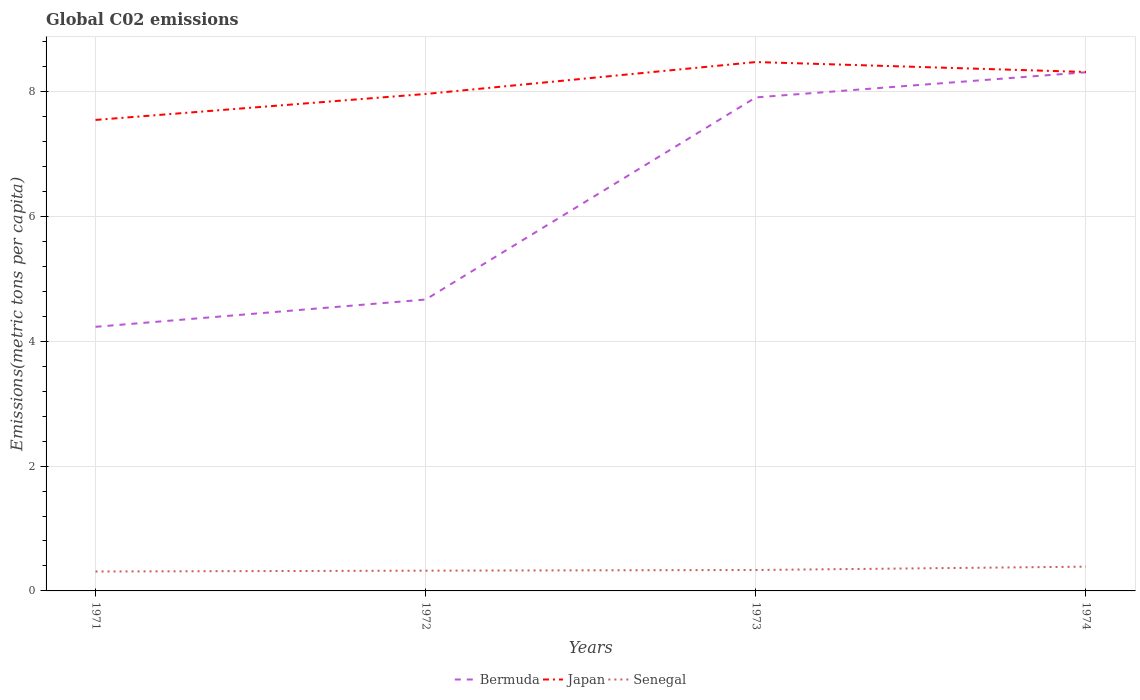Is the number of lines equal to the number of legend labels?
Your answer should be very brief. Yes. Across all years, what is the maximum amount of CO2 emitted in in Senegal?
Ensure brevity in your answer.  0.31. What is the total amount of CO2 emitted in in Senegal in the graph?
Give a very brief answer. -0.06. What is the difference between the highest and the second highest amount of CO2 emitted in in Senegal?
Offer a terse response. 0.08. Is the amount of CO2 emitted in in Japan strictly greater than the amount of CO2 emitted in in Senegal over the years?
Give a very brief answer. No. How many lines are there?
Give a very brief answer. 3. What is the difference between two consecutive major ticks on the Y-axis?
Provide a succinct answer. 2. Are the values on the major ticks of Y-axis written in scientific E-notation?
Offer a terse response. No. Does the graph contain any zero values?
Your response must be concise. No. Does the graph contain grids?
Give a very brief answer. Yes. How many legend labels are there?
Provide a succinct answer. 3. What is the title of the graph?
Your answer should be compact. Global C02 emissions. What is the label or title of the Y-axis?
Provide a succinct answer. Emissions(metric tons per capita). What is the Emissions(metric tons per capita) of Bermuda in 1971?
Keep it short and to the point. 4.23. What is the Emissions(metric tons per capita) in Japan in 1971?
Offer a very short reply. 7.55. What is the Emissions(metric tons per capita) of Senegal in 1971?
Ensure brevity in your answer.  0.31. What is the Emissions(metric tons per capita) of Bermuda in 1972?
Your answer should be very brief. 4.67. What is the Emissions(metric tons per capita) in Japan in 1972?
Offer a very short reply. 7.96. What is the Emissions(metric tons per capita) of Senegal in 1972?
Provide a succinct answer. 0.32. What is the Emissions(metric tons per capita) in Bermuda in 1973?
Provide a succinct answer. 7.91. What is the Emissions(metric tons per capita) of Japan in 1973?
Provide a short and direct response. 8.47. What is the Emissions(metric tons per capita) of Senegal in 1973?
Provide a succinct answer. 0.34. What is the Emissions(metric tons per capita) in Bermuda in 1974?
Your answer should be very brief. 8.31. What is the Emissions(metric tons per capita) of Japan in 1974?
Provide a succinct answer. 8.31. What is the Emissions(metric tons per capita) in Senegal in 1974?
Ensure brevity in your answer.  0.39. Across all years, what is the maximum Emissions(metric tons per capita) of Bermuda?
Your response must be concise. 8.31. Across all years, what is the maximum Emissions(metric tons per capita) of Japan?
Your response must be concise. 8.47. Across all years, what is the maximum Emissions(metric tons per capita) of Senegal?
Offer a terse response. 0.39. Across all years, what is the minimum Emissions(metric tons per capita) of Bermuda?
Provide a short and direct response. 4.23. Across all years, what is the minimum Emissions(metric tons per capita) in Japan?
Offer a very short reply. 7.55. Across all years, what is the minimum Emissions(metric tons per capita) in Senegal?
Your response must be concise. 0.31. What is the total Emissions(metric tons per capita) of Bermuda in the graph?
Make the answer very short. 25.12. What is the total Emissions(metric tons per capita) in Japan in the graph?
Provide a succinct answer. 32.29. What is the total Emissions(metric tons per capita) of Senegal in the graph?
Give a very brief answer. 1.36. What is the difference between the Emissions(metric tons per capita) in Bermuda in 1971 and that in 1972?
Your answer should be compact. -0.44. What is the difference between the Emissions(metric tons per capita) in Japan in 1971 and that in 1972?
Your response must be concise. -0.42. What is the difference between the Emissions(metric tons per capita) of Senegal in 1971 and that in 1972?
Your response must be concise. -0.01. What is the difference between the Emissions(metric tons per capita) of Bermuda in 1971 and that in 1973?
Make the answer very short. -3.68. What is the difference between the Emissions(metric tons per capita) in Japan in 1971 and that in 1973?
Provide a short and direct response. -0.93. What is the difference between the Emissions(metric tons per capita) of Senegal in 1971 and that in 1973?
Give a very brief answer. -0.02. What is the difference between the Emissions(metric tons per capita) in Bermuda in 1971 and that in 1974?
Your answer should be compact. -4.08. What is the difference between the Emissions(metric tons per capita) of Japan in 1971 and that in 1974?
Offer a terse response. -0.77. What is the difference between the Emissions(metric tons per capita) in Senegal in 1971 and that in 1974?
Give a very brief answer. -0.08. What is the difference between the Emissions(metric tons per capita) of Bermuda in 1972 and that in 1973?
Ensure brevity in your answer.  -3.24. What is the difference between the Emissions(metric tons per capita) of Japan in 1972 and that in 1973?
Your response must be concise. -0.51. What is the difference between the Emissions(metric tons per capita) in Senegal in 1972 and that in 1973?
Provide a short and direct response. -0.01. What is the difference between the Emissions(metric tons per capita) of Bermuda in 1972 and that in 1974?
Give a very brief answer. -3.64. What is the difference between the Emissions(metric tons per capita) of Japan in 1972 and that in 1974?
Ensure brevity in your answer.  -0.35. What is the difference between the Emissions(metric tons per capita) of Senegal in 1972 and that in 1974?
Offer a terse response. -0.06. What is the difference between the Emissions(metric tons per capita) in Bermuda in 1973 and that in 1974?
Give a very brief answer. -0.4. What is the difference between the Emissions(metric tons per capita) in Japan in 1973 and that in 1974?
Your answer should be very brief. 0.16. What is the difference between the Emissions(metric tons per capita) in Senegal in 1973 and that in 1974?
Your answer should be compact. -0.05. What is the difference between the Emissions(metric tons per capita) in Bermuda in 1971 and the Emissions(metric tons per capita) in Japan in 1972?
Provide a short and direct response. -3.73. What is the difference between the Emissions(metric tons per capita) of Bermuda in 1971 and the Emissions(metric tons per capita) of Senegal in 1972?
Offer a terse response. 3.91. What is the difference between the Emissions(metric tons per capita) of Japan in 1971 and the Emissions(metric tons per capita) of Senegal in 1972?
Keep it short and to the point. 7.22. What is the difference between the Emissions(metric tons per capita) of Bermuda in 1971 and the Emissions(metric tons per capita) of Japan in 1973?
Provide a short and direct response. -4.24. What is the difference between the Emissions(metric tons per capita) in Bermuda in 1971 and the Emissions(metric tons per capita) in Senegal in 1973?
Offer a very short reply. 3.9. What is the difference between the Emissions(metric tons per capita) of Japan in 1971 and the Emissions(metric tons per capita) of Senegal in 1973?
Ensure brevity in your answer.  7.21. What is the difference between the Emissions(metric tons per capita) in Bermuda in 1971 and the Emissions(metric tons per capita) in Japan in 1974?
Give a very brief answer. -4.08. What is the difference between the Emissions(metric tons per capita) of Bermuda in 1971 and the Emissions(metric tons per capita) of Senegal in 1974?
Give a very brief answer. 3.84. What is the difference between the Emissions(metric tons per capita) of Japan in 1971 and the Emissions(metric tons per capita) of Senegal in 1974?
Offer a very short reply. 7.16. What is the difference between the Emissions(metric tons per capita) in Bermuda in 1972 and the Emissions(metric tons per capita) in Japan in 1973?
Ensure brevity in your answer.  -3.8. What is the difference between the Emissions(metric tons per capita) in Bermuda in 1972 and the Emissions(metric tons per capita) in Senegal in 1973?
Offer a very short reply. 4.33. What is the difference between the Emissions(metric tons per capita) of Japan in 1972 and the Emissions(metric tons per capita) of Senegal in 1973?
Provide a short and direct response. 7.63. What is the difference between the Emissions(metric tons per capita) in Bermuda in 1972 and the Emissions(metric tons per capita) in Japan in 1974?
Your answer should be compact. -3.65. What is the difference between the Emissions(metric tons per capita) of Bermuda in 1972 and the Emissions(metric tons per capita) of Senegal in 1974?
Offer a terse response. 4.28. What is the difference between the Emissions(metric tons per capita) in Japan in 1972 and the Emissions(metric tons per capita) in Senegal in 1974?
Make the answer very short. 7.57. What is the difference between the Emissions(metric tons per capita) of Bermuda in 1973 and the Emissions(metric tons per capita) of Japan in 1974?
Make the answer very short. -0.41. What is the difference between the Emissions(metric tons per capita) of Bermuda in 1973 and the Emissions(metric tons per capita) of Senegal in 1974?
Ensure brevity in your answer.  7.52. What is the difference between the Emissions(metric tons per capita) of Japan in 1973 and the Emissions(metric tons per capita) of Senegal in 1974?
Offer a terse response. 8.08. What is the average Emissions(metric tons per capita) of Bermuda per year?
Offer a terse response. 6.28. What is the average Emissions(metric tons per capita) in Japan per year?
Your answer should be compact. 8.07. What is the average Emissions(metric tons per capita) in Senegal per year?
Offer a terse response. 0.34. In the year 1971, what is the difference between the Emissions(metric tons per capita) in Bermuda and Emissions(metric tons per capita) in Japan?
Your answer should be compact. -3.31. In the year 1971, what is the difference between the Emissions(metric tons per capita) of Bermuda and Emissions(metric tons per capita) of Senegal?
Ensure brevity in your answer.  3.92. In the year 1971, what is the difference between the Emissions(metric tons per capita) in Japan and Emissions(metric tons per capita) in Senegal?
Offer a terse response. 7.23. In the year 1972, what is the difference between the Emissions(metric tons per capita) of Bermuda and Emissions(metric tons per capita) of Japan?
Give a very brief answer. -3.29. In the year 1972, what is the difference between the Emissions(metric tons per capita) in Bermuda and Emissions(metric tons per capita) in Senegal?
Keep it short and to the point. 4.34. In the year 1972, what is the difference between the Emissions(metric tons per capita) of Japan and Emissions(metric tons per capita) of Senegal?
Provide a succinct answer. 7.64. In the year 1973, what is the difference between the Emissions(metric tons per capita) in Bermuda and Emissions(metric tons per capita) in Japan?
Make the answer very short. -0.57. In the year 1973, what is the difference between the Emissions(metric tons per capita) in Bermuda and Emissions(metric tons per capita) in Senegal?
Provide a succinct answer. 7.57. In the year 1973, what is the difference between the Emissions(metric tons per capita) in Japan and Emissions(metric tons per capita) in Senegal?
Offer a terse response. 8.14. In the year 1974, what is the difference between the Emissions(metric tons per capita) of Bermuda and Emissions(metric tons per capita) of Japan?
Give a very brief answer. -0. In the year 1974, what is the difference between the Emissions(metric tons per capita) of Bermuda and Emissions(metric tons per capita) of Senegal?
Make the answer very short. 7.92. In the year 1974, what is the difference between the Emissions(metric tons per capita) of Japan and Emissions(metric tons per capita) of Senegal?
Your answer should be very brief. 7.93. What is the ratio of the Emissions(metric tons per capita) in Bermuda in 1971 to that in 1972?
Your answer should be compact. 0.91. What is the ratio of the Emissions(metric tons per capita) of Japan in 1971 to that in 1972?
Keep it short and to the point. 0.95. What is the ratio of the Emissions(metric tons per capita) of Senegal in 1971 to that in 1972?
Make the answer very short. 0.96. What is the ratio of the Emissions(metric tons per capita) in Bermuda in 1971 to that in 1973?
Your answer should be compact. 0.54. What is the ratio of the Emissions(metric tons per capita) of Japan in 1971 to that in 1973?
Provide a succinct answer. 0.89. What is the ratio of the Emissions(metric tons per capita) in Senegal in 1971 to that in 1973?
Ensure brevity in your answer.  0.93. What is the ratio of the Emissions(metric tons per capita) in Bermuda in 1971 to that in 1974?
Your answer should be very brief. 0.51. What is the ratio of the Emissions(metric tons per capita) of Japan in 1971 to that in 1974?
Your response must be concise. 0.91. What is the ratio of the Emissions(metric tons per capita) in Senegal in 1971 to that in 1974?
Provide a succinct answer. 0.8. What is the ratio of the Emissions(metric tons per capita) of Bermuda in 1972 to that in 1973?
Offer a terse response. 0.59. What is the ratio of the Emissions(metric tons per capita) in Japan in 1972 to that in 1973?
Your response must be concise. 0.94. What is the ratio of the Emissions(metric tons per capita) of Senegal in 1972 to that in 1973?
Your answer should be compact. 0.97. What is the ratio of the Emissions(metric tons per capita) of Bermuda in 1972 to that in 1974?
Offer a very short reply. 0.56. What is the ratio of the Emissions(metric tons per capita) of Japan in 1972 to that in 1974?
Keep it short and to the point. 0.96. What is the ratio of the Emissions(metric tons per capita) of Senegal in 1972 to that in 1974?
Provide a succinct answer. 0.84. What is the ratio of the Emissions(metric tons per capita) of Bermuda in 1973 to that in 1974?
Make the answer very short. 0.95. What is the ratio of the Emissions(metric tons per capita) in Japan in 1973 to that in 1974?
Your answer should be compact. 1.02. What is the ratio of the Emissions(metric tons per capita) of Senegal in 1973 to that in 1974?
Your answer should be very brief. 0.86. What is the difference between the highest and the second highest Emissions(metric tons per capita) of Bermuda?
Offer a very short reply. 0.4. What is the difference between the highest and the second highest Emissions(metric tons per capita) in Japan?
Offer a terse response. 0.16. What is the difference between the highest and the second highest Emissions(metric tons per capita) of Senegal?
Make the answer very short. 0.05. What is the difference between the highest and the lowest Emissions(metric tons per capita) in Bermuda?
Your answer should be compact. 4.08. What is the difference between the highest and the lowest Emissions(metric tons per capita) of Japan?
Provide a succinct answer. 0.93. What is the difference between the highest and the lowest Emissions(metric tons per capita) of Senegal?
Your response must be concise. 0.08. 